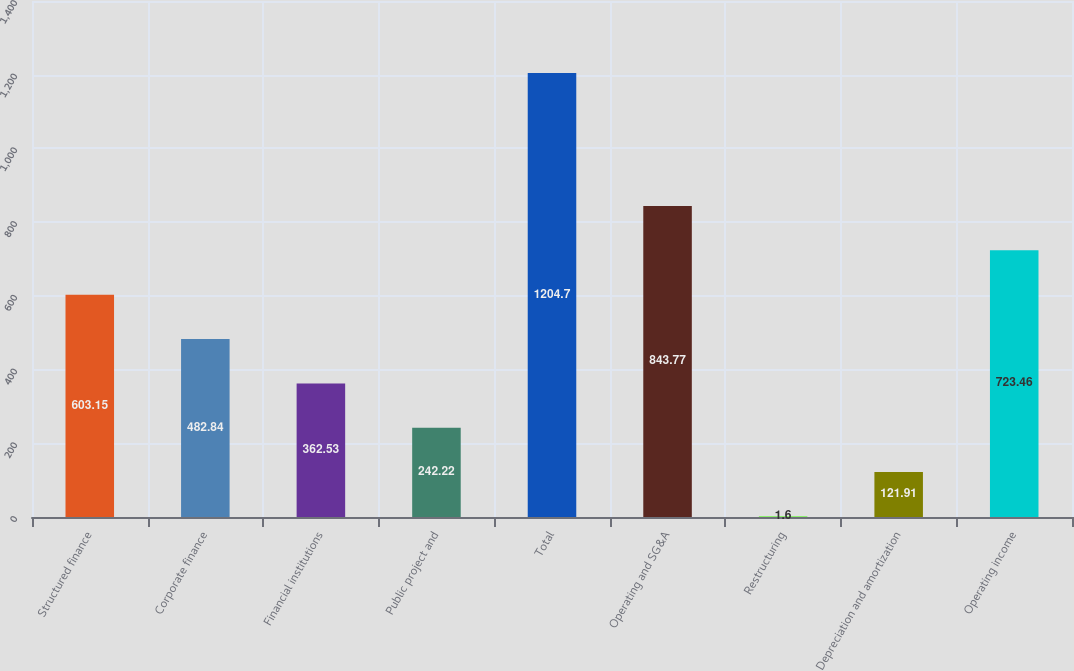<chart> <loc_0><loc_0><loc_500><loc_500><bar_chart><fcel>Structured finance<fcel>Corporate finance<fcel>Financial institutions<fcel>Public project and<fcel>Total<fcel>Operating and SG&A<fcel>Restructuring<fcel>Depreciation and amortization<fcel>Operating income<nl><fcel>603.15<fcel>482.84<fcel>362.53<fcel>242.22<fcel>1204.7<fcel>843.77<fcel>1.6<fcel>121.91<fcel>723.46<nl></chart> 